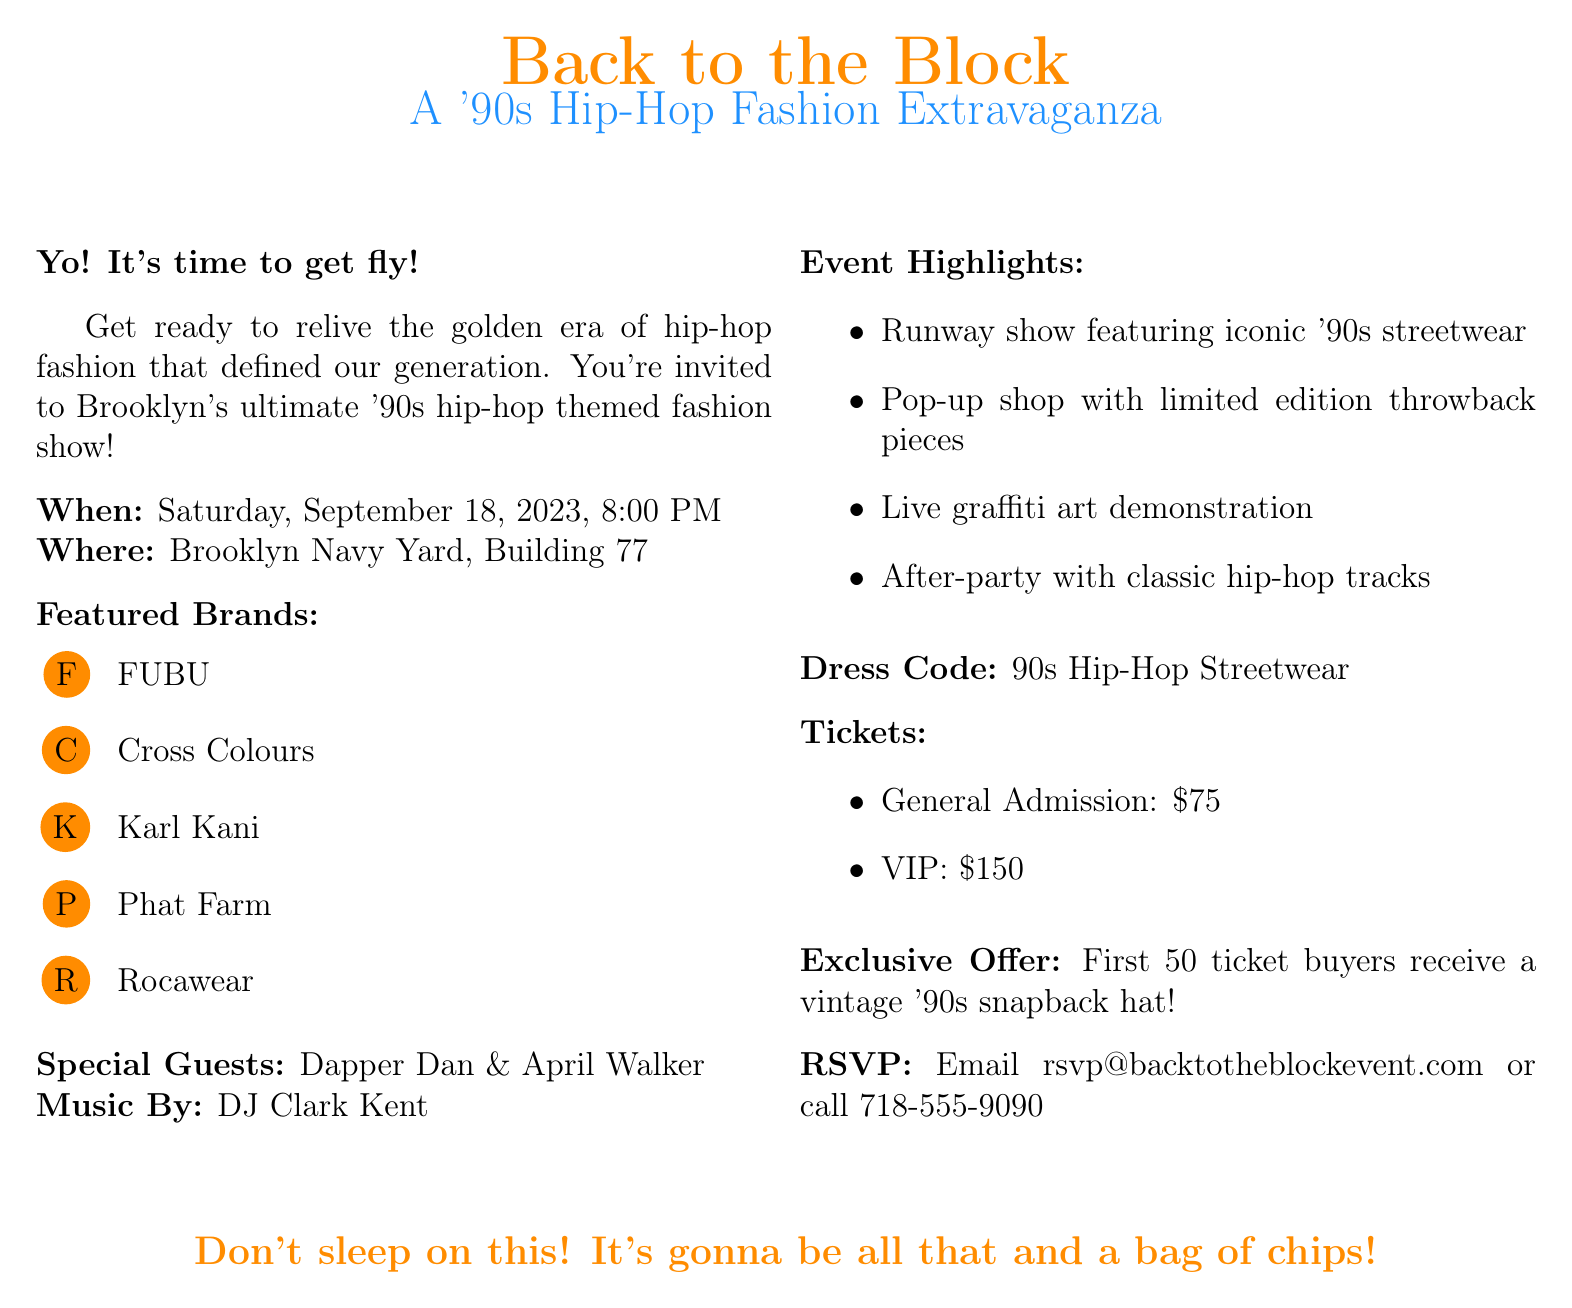What is the name of the event? The document states that the event is called "Back to the Block: A '90s Hip-Hop Fashion Extravaganza."
Answer: Back to the Block: A '90s Hip-Hop Fashion Extravaganza When is the fashion show scheduled? The event is set for Saturday, September 18, 2023, at 8:00 PM.
Answer: Saturday, September 18, 2023, 8:00 PM Where will the fashion show take place? The location mentioned in the document is the Brooklyn Navy Yard, Building 77.
Answer: Brooklyn Navy Yard, Building 77 Who are the special guests at the event? The document lists Dapper Dan and April Walker as special guests.
Answer: Dapper Dan and April Walker What is the ticket price for VIP admission? The document states that VIP tickets cost $150.
Answer: $150 What is the dress code for the event? The dress code specified in the document is "90s Hip-Hop Streetwear."
Answer: 90s Hip-Hop Streetwear What will the first 50 ticket buyers receive? The document mentions that they will receive a vintage '90s snapback hat.
Answer: A vintage '90s snapback hat Who is the music DJ for the event? According to the document, DJ Clark Kent will be providing the music.
Answer: DJ Clark Kent What type of event highlight involves live art? The document states there will be a live graffiti art demonstration as a highlight.
Answer: Live graffiti art demonstration 